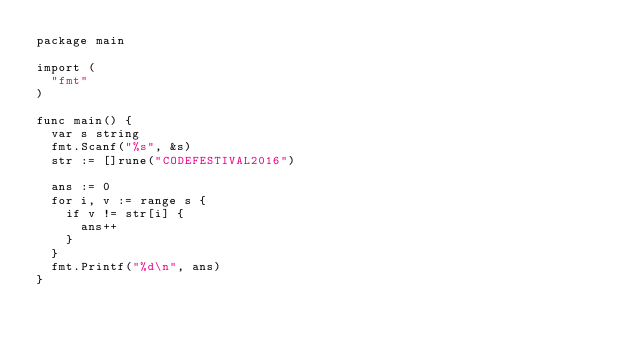Convert code to text. <code><loc_0><loc_0><loc_500><loc_500><_Go_>package main

import (
  "fmt"
)

func main() {
  var s string
  fmt.Scanf("%s", &s)
  str := []rune("CODEFESTIVAL2016")
  
  ans := 0
  for i, v := range s {
    if v != str[i] {
      ans++
    }
  }
  fmt.Printf("%d\n", ans)
}</code> 